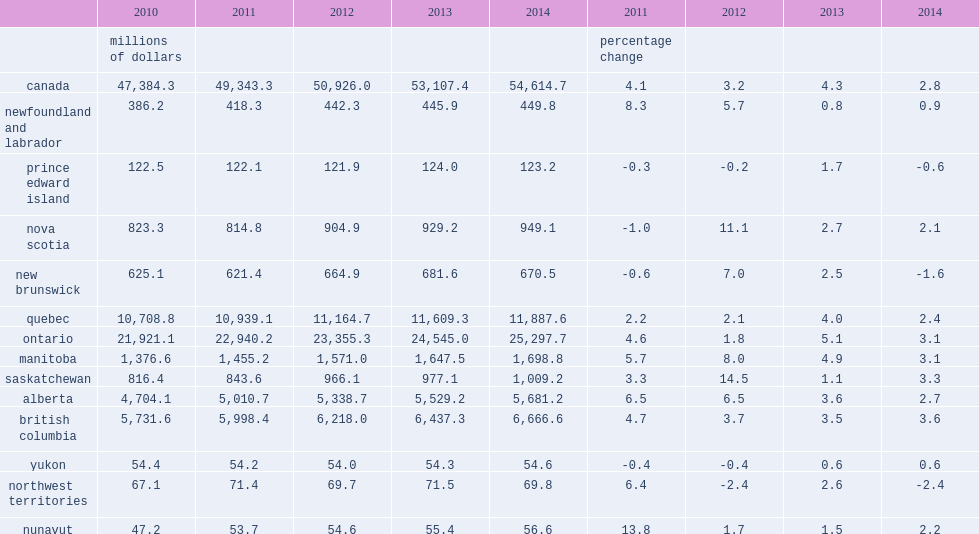What was the percentage did culture gdp in canada rise in 2014? 2.8. What was the percentage did culture gdp in canada rise in 2013? 4.3. What was the percentage did culture gdp increased in all provinces and territories except new brunswick? -2.4. What was the percentage did culture gdp increased in all provinces and territories except new brunswick? -1.6. What was the percentage did culture gdp increased in all provinces and territories except prince edward island? -0.6. What was the percentage of culture gdp in newfoundland and labrador rose in 2014? 0.9. What was the percentage of prince edward island's culture gdp contracted in 2014? 0.6. What was the percentage of prince edward island's culture gdp gain in 2013? 1.7. What was the percentage of culture gdp in nova scotia grew in 2014? 2.1. What was the percentage of culture gdp in nova scotia grew in 2013? 2.7. What was the percentage of culture gdp in new brunswick contracted in 2014? 1.6. What was the percentage of culture gdp in new brunswick increased in 2013? 2.5. What was the percentage of quebec's culture gdp grew in 2014? 2.4. What was the percentage of quebec's culture gdp grew in 2013? 4.0. What was the percentage of quebec's culture gdp grew in 2014? 3.1. What was the percentage of quebec's culture gdp grew in 2013? 5.1. What was the percentage of manitoba's culture gdp grew in 2014? 3.1. What was the percentage of manitoba's culture gdp grew in 2013? 4.9. What was the percentage of saskatchewan's culture gdp grew in 2014? 3.3. What was the percentage of saskatchewan's culture gdp grew in 2013? 1.1. What was the percentage of alberta's culture gdp rose in 2014? 2.7. What was the percentage of alberta's culture gdp rose in 2013? 3.6. What was the percentage of culture gdp in british columbia grew in 2014? 3.6. What was the percentage of culture gdp in yukon rose in 2014? 0.6. What was the percentage of culture gdp in the northwest territories retracted in 2014? 2.4. What was the percentage of culture gdp in the northwest territories increased in 2013? 2.6. What was the percentage of nunavut's culture gdp grew in 2014? 2.2. What was the percentage of nunavut's culture gdp grew in 2013? 1.5. 